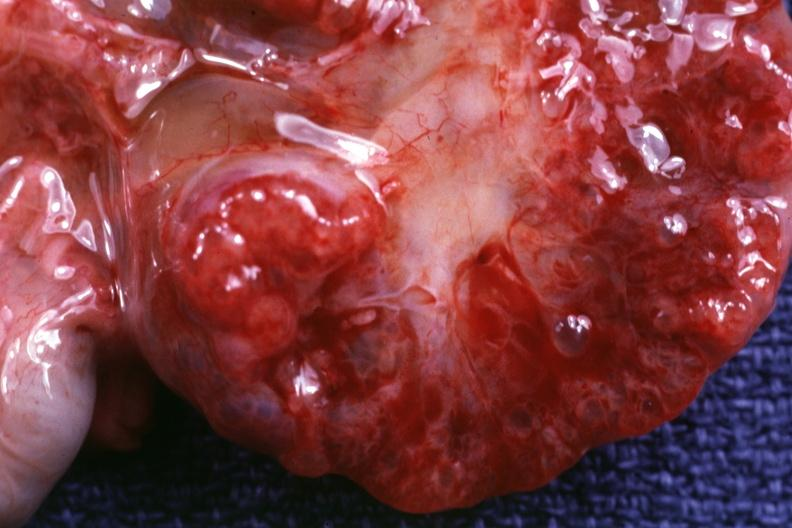s no tissue recognizable as ovary present?
Answer the question using a single word or phrase. No 